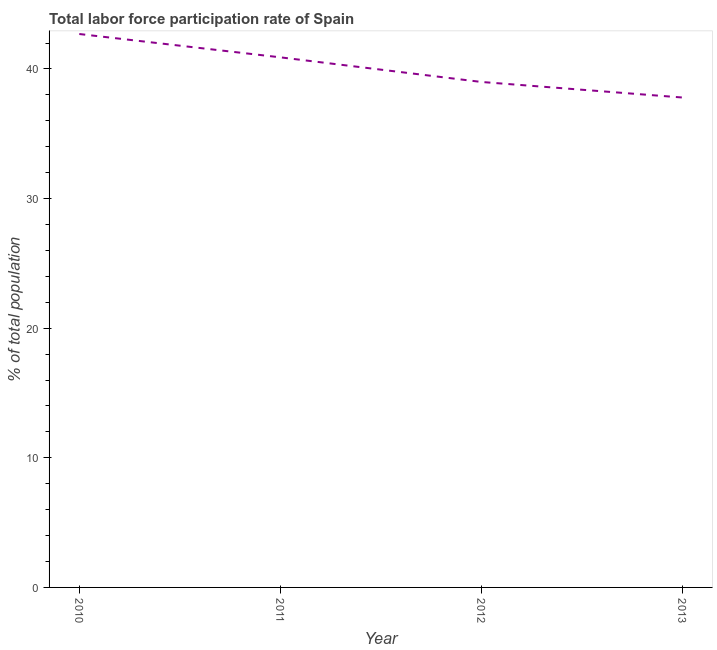What is the total labor force participation rate in 2013?
Keep it short and to the point. 37.8. Across all years, what is the maximum total labor force participation rate?
Offer a very short reply. 42.7. Across all years, what is the minimum total labor force participation rate?
Provide a succinct answer. 37.8. What is the sum of the total labor force participation rate?
Give a very brief answer. 160.4. What is the difference between the total labor force participation rate in 2010 and 2012?
Offer a very short reply. 3.7. What is the average total labor force participation rate per year?
Provide a short and direct response. 40.1. What is the median total labor force participation rate?
Provide a succinct answer. 39.95. Do a majority of the years between 2013 and 2012 (inclusive) have total labor force participation rate greater than 20 %?
Your answer should be very brief. No. What is the ratio of the total labor force participation rate in 2010 to that in 2011?
Keep it short and to the point. 1.04. What is the difference between the highest and the second highest total labor force participation rate?
Your answer should be very brief. 1.8. What is the difference between the highest and the lowest total labor force participation rate?
Provide a succinct answer. 4.9. What is the difference between two consecutive major ticks on the Y-axis?
Your answer should be very brief. 10. Does the graph contain grids?
Your answer should be very brief. No. What is the title of the graph?
Offer a terse response. Total labor force participation rate of Spain. What is the label or title of the Y-axis?
Provide a short and direct response. % of total population. What is the % of total population in 2010?
Your response must be concise. 42.7. What is the % of total population in 2011?
Your response must be concise. 40.9. What is the % of total population of 2013?
Give a very brief answer. 37.8. What is the difference between the % of total population in 2010 and 2012?
Your response must be concise. 3.7. What is the difference between the % of total population in 2010 and 2013?
Your answer should be compact. 4.9. What is the difference between the % of total population in 2012 and 2013?
Offer a terse response. 1.2. What is the ratio of the % of total population in 2010 to that in 2011?
Provide a succinct answer. 1.04. What is the ratio of the % of total population in 2010 to that in 2012?
Provide a short and direct response. 1.09. What is the ratio of the % of total population in 2010 to that in 2013?
Provide a short and direct response. 1.13. What is the ratio of the % of total population in 2011 to that in 2012?
Make the answer very short. 1.05. What is the ratio of the % of total population in 2011 to that in 2013?
Your response must be concise. 1.08. What is the ratio of the % of total population in 2012 to that in 2013?
Provide a succinct answer. 1.03. 